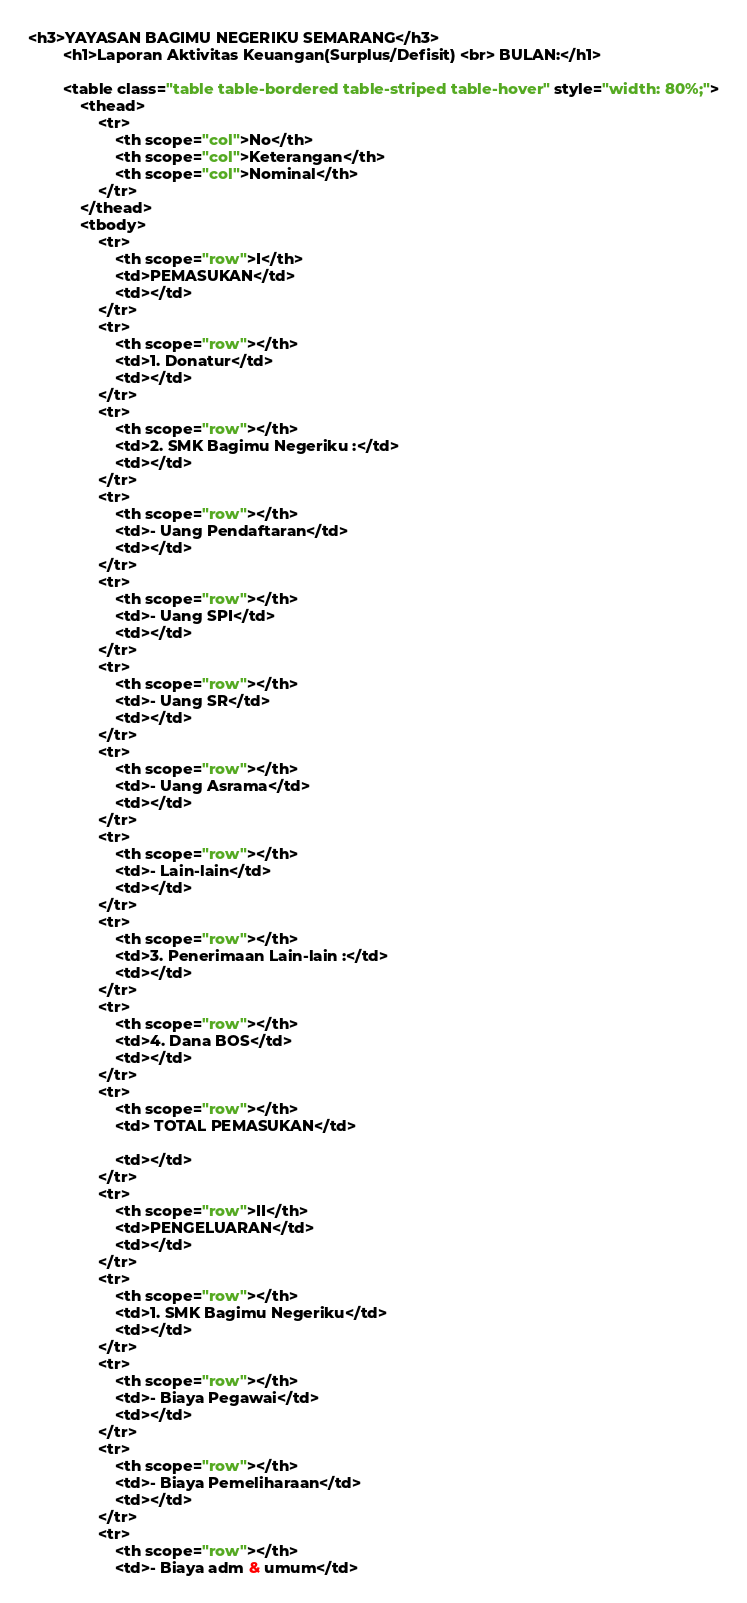Convert code to text. <code><loc_0><loc_0><loc_500><loc_500><_HTML_><h3>YAYASAN BAGIMU NEGERIKU SEMARANG</h3>
        <h1>Laporan Aktivitas Keuangan(Surplus/Defisit) <br> BULAN:</h1>

        <table class="table table-bordered table-striped table-hover" style="width: 80%;">
            <thead>
                <tr>
                    <th scope="col">No</th>
                    <th scope="col">Keterangan</th>
                    <th scope="col">Nominal</th>
                </tr>
            </thead>
            <tbody>
                <tr>
                    <th scope="row">I</th>
                    <td>PEMASUKAN</td>
                    <td></td>
                </tr>
                <tr>
                    <th scope="row"></th>
                    <td>1. Donatur</td>
                    <td></td>
                </tr>
                <tr>
                    <th scope="row"></th>
                    <td>2. SMK Bagimu Negeriku :</td>
                    <td></td>
                </tr>
                <tr>
                    <th scope="row"></th>
                    <td>- Uang Pendaftaran</td>
                    <td></td>
                </tr>
                <tr>
                    <th scope="row"></th>
                    <td>- Uang SPI</td>
                    <td></td>
                </tr>
                <tr>
                    <th scope="row"></th>
                    <td>- Uang SR</td>
                    <td></td>
                </tr>
                <tr>
                    <th scope="row"></th>
                    <td>- Uang Asrama</td>
                    <td></td>
                </tr>
                <tr>
                    <th scope="row"></th>
                    <td>- Lain-lain</td>
                    <td></td>
                </tr>
                <tr>
                    <th scope="row"></th>
                    <td>3. Penerimaan Lain-lain :</td>
                    <td></td>
                </tr>
                <tr>
                    <th scope="row"></th>
                    <td>4. Dana BOS</td>
                    <td></td>
                </tr>
                <tr>
                    <th scope="row"></th>
                    <td> TOTAL PEMASUKAN</td>
                        
                    <td></td>
                </tr>
                <tr>
                    <th scope="row">II</th>
                    <td>PENGELUARAN</td>
                    <td></td>
                </tr>
                <tr>
                    <th scope="row"></th>
                    <td>1. SMK Bagimu Negeriku</td>
                    <td></td>
                </tr>
                <tr>
                    <th scope="row"></th>
                    <td>- Biaya Pegawai</td>
                    <td></td>
                </tr>
                <tr>
                    <th scope="row"></th>
                    <td>- Biaya Pemeliharaan</td>
                    <td></td>
                </tr>
                <tr>
                    <th scope="row"></th>
                    <td>- Biaya adm & umum</td></code> 